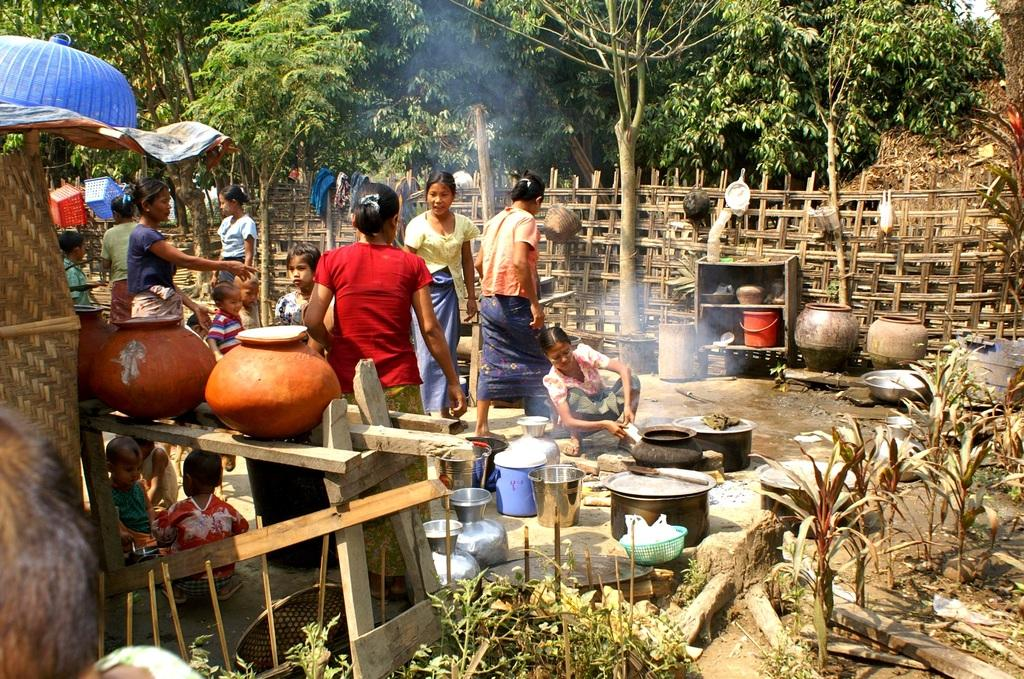What can be seen in the image related to cooking? A woman is cooking something in the image. What else is present in the image besides the woman cooking? There are many utensils visible in the image. Can you describe the people behind the woman? There are many people behind the woman, and they are surrounded by a fence. What is visible behind the fence? There are many trees behind the fence. What type of basket is being used by the porter in the image? There is no porter or basket present in the image. 